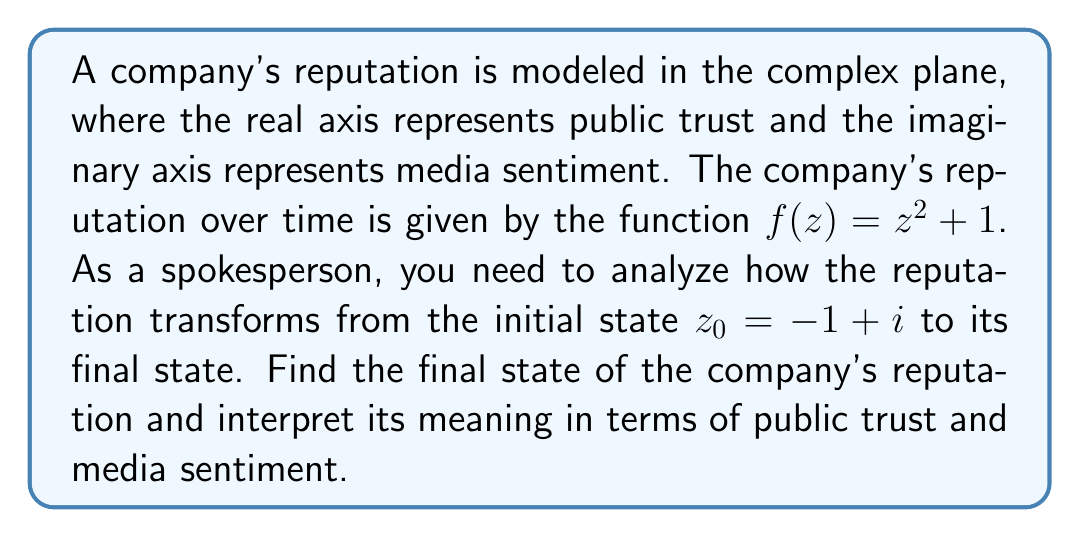Help me with this question. To solve this problem, we need to apply the given conformal mapping $f(z) = z^2 + 1$ to the initial state $z_0 = -1 + i$. Let's break it down step by step:

1) First, we need to calculate $f(z_0)$:
   
   $f(z_0) = z_0^2 + 1$
   
2) Substitute $z_0 = -1 + i$:
   
   $f(-1 + i) = (-1 + i)^2 + 1$

3) To square the complex number, we use the formula $(a+bi)^2 = (a^2-b^2) + (2ab)i$:
   
   $(-1 + i)^2 = (-1)^2 - (1)^2 + 2(-1)(1)i = 1 - 1 - 2i = -2i$

4) Now we add 1 to this result:
   
   $f(-1 + i) = (-2i) + 1 = 1 - 2i$

5) This final complex number, $1 - 2i$, represents the transformed state of the company's reputation.

Interpretation:
- The real part (1) represents public trust. It has increased from -1 to 1, indicating an improvement in public trust.
- The imaginary part (-2) represents media sentiment. It has decreased from 1 to -2, indicating a more negative media sentiment.

As a spokesperson, you could interpret this as: "Our efforts have successfully improved public trust, but we still face challenges in media perception. Our next steps should focus on improving our media relations while maintaining the gained public trust."
Answer: $f(-1 + i) = 1 - 2i$ 